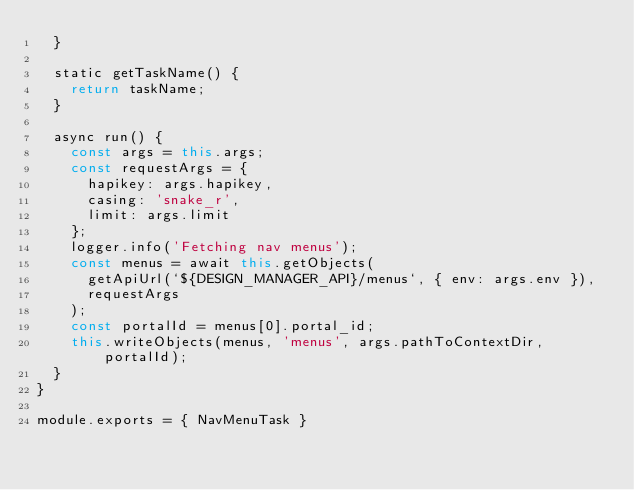<code> <loc_0><loc_0><loc_500><loc_500><_JavaScript_>  }

  static getTaskName() {
    return taskName;
  }

  async run() {
    const args = this.args;
    const requestArgs = {
      hapikey: args.hapikey,
      casing: 'snake_r',
      limit: args.limit
    };
    logger.info('Fetching nav menus');
    const menus = await this.getObjects(
      getApiUrl(`${DESIGN_MANAGER_API}/menus`, { env: args.env }),
      requestArgs
    );
    const portalId = menus[0].portal_id;
    this.writeObjects(menus, 'menus', args.pathToContextDir, portalId);
  }
}

module.exports = { NavMenuTask }
</code> 